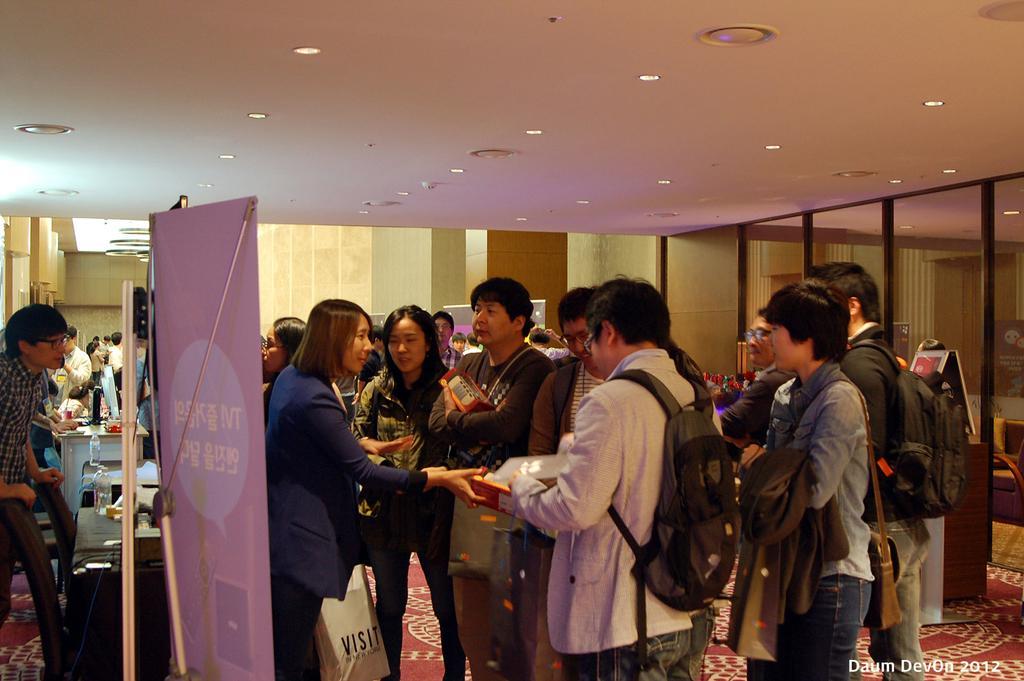Please provide a concise description of this image. In this image I can see group of people standing. In front the person is wearing blue color dress and I can also see the board. In the background I can see few glass walls, lights and the wall is in cream color. 